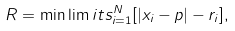Convert formula to latex. <formula><loc_0><loc_0><loc_500><loc_500>R = \min \lim i t s _ { i = 1 } ^ { N } [ | { x } _ { i } - { p } | - r _ { i } ] ,</formula> 